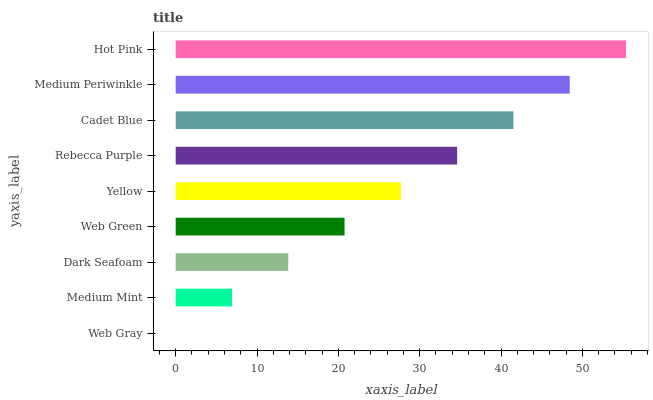Is Web Gray the minimum?
Answer yes or no. Yes. Is Hot Pink the maximum?
Answer yes or no. Yes. Is Medium Mint the minimum?
Answer yes or no. No. Is Medium Mint the maximum?
Answer yes or no. No. Is Medium Mint greater than Web Gray?
Answer yes or no. Yes. Is Web Gray less than Medium Mint?
Answer yes or no. Yes. Is Web Gray greater than Medium Mint?
Answer yes or no. No. Is Medium Mint less than Web Gray?
Answer yes or no. No. Is Yellow the high median?
Answer yes or no. Yes. Is Yellow the low median?
Answer yes or no. Yes. Is Web Green the high median?
Answer yes or no. No. Is Web Gray the low median?
Answer yes or no. No. 